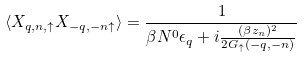<formula> <loc_0><loc_0><loc_500><loc_500>\left < X _ { { q } , n , \uparrow } X _ { - { q } , - n \uparrow } \right > = \frac { 1 } { \beta N ^ { 0 } \epsilon _ { q } + i \frac { ( \beta z _ { n } ) ^ { 2 } } { 2 G _ { \uparrow } ( - { q } , - n ) } }</formula> 